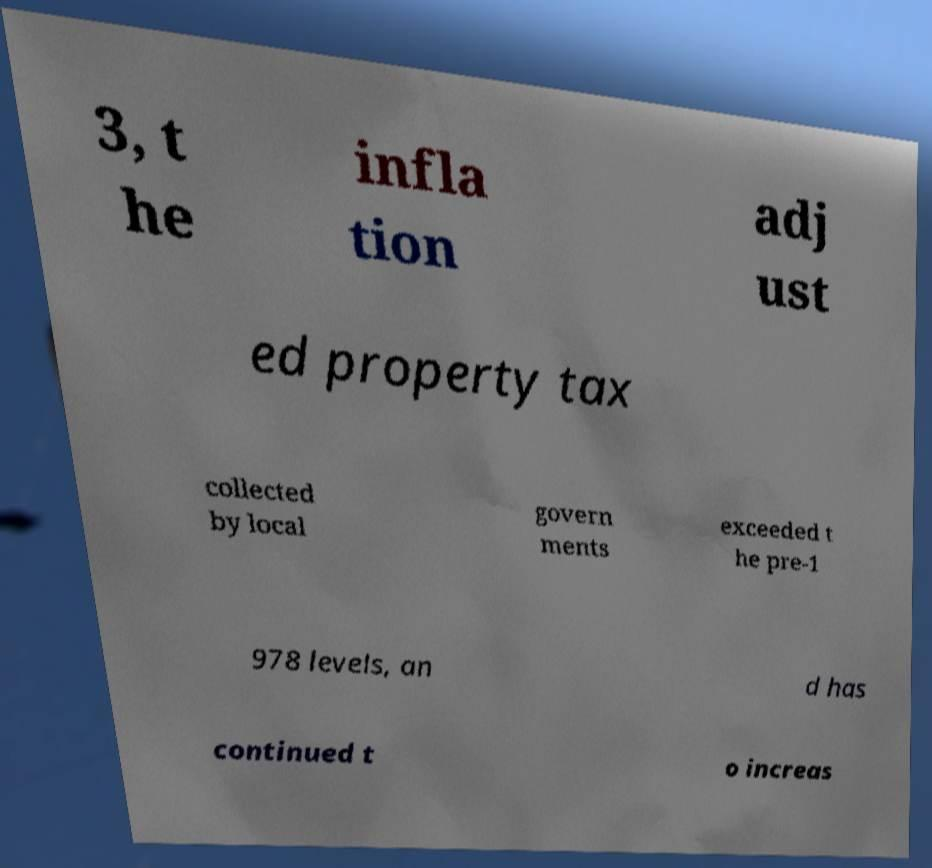Please read and relay the text visible in this image. What does it say? 3, t he infla tion adj ust ed property tax collected by local govern ments exceeded t he pre-1 978 levels, an d has continued t o increas 